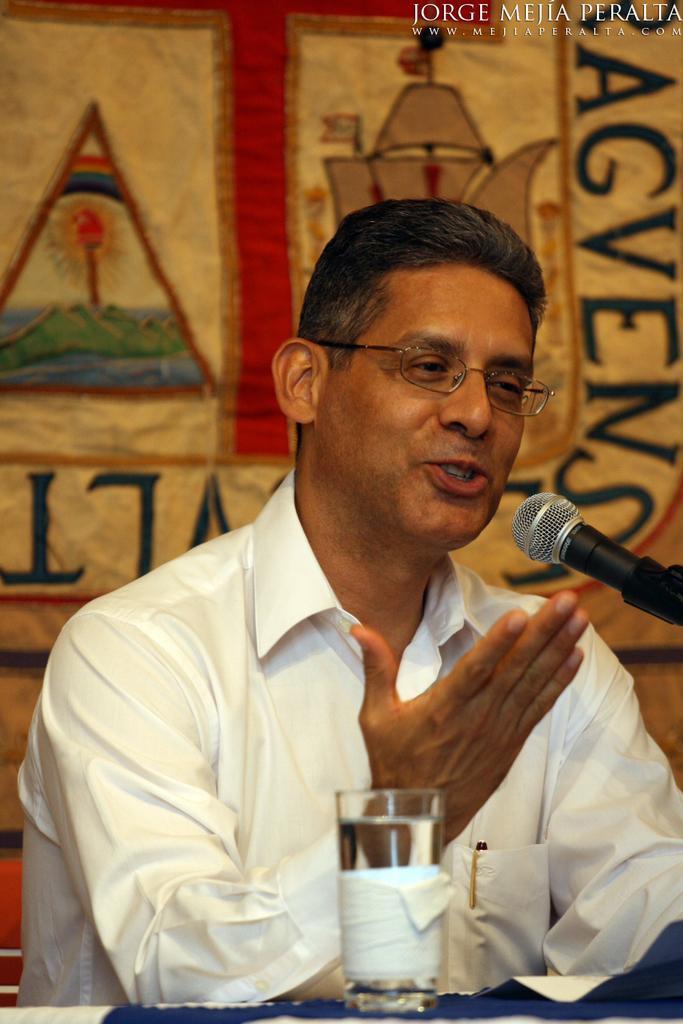In one or two sentences, can you explain what this image depicts? In this image we can see there is a person talking. There is a microphone and a glass. In the background we can see a banner.  